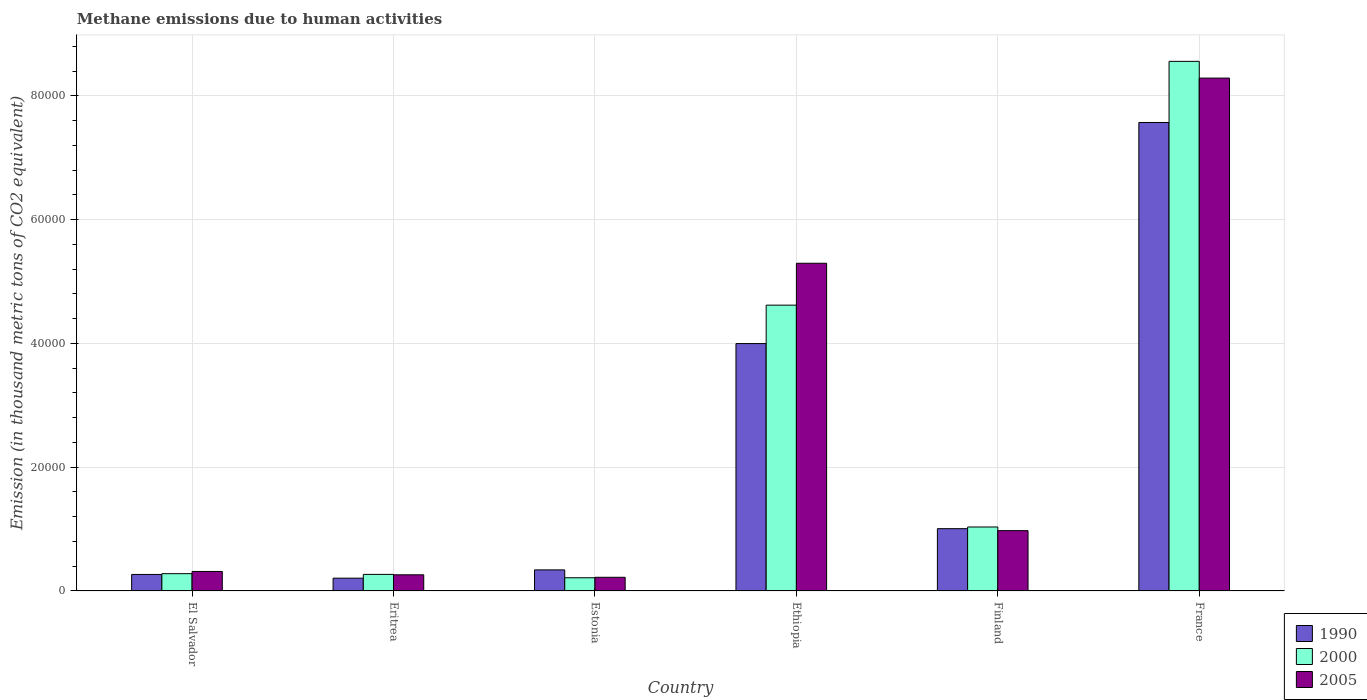How many different coloured bars are there?
Your answer should be very brief. 3. How many bars are there on the 2nd tick from the left?
Provide a short and direct response. 3. How many bars are there on the 1st tick from the right?
Offer a terse response. 3. What is the label of the 1st group of bars from the left?
Provide a succinct answer. El Salvador. What is the amount of methane emitted in 2000 in Ethiopia?
Provide a short and direct response. 4.62e+04. Across all countries, what is the maximum amount of methane emitted in 1990?
Provide a short and direct response. 7.57e+04. Across all countries, what is the minimum amount of methane emitted in 1990?
Offer a very short reply. 2070.6. In which country was the amount of methane emitted in 2005 maximum?
Offer a very short reply. France. In which country was the amount of methane emitted in 2005 minimum?
Ensure brevity in your answer.  Estonia. What is the total amount of methane emitted in 2000 in the graph?
Offer a very short reply. 1.50e+05. What is the difference between the amount of methane emitted in 2000 in Ethiopia and that in Finland?
Keep it short and to the point. 3.59e+04. What is the difference between the amount of methane emitted in 2005 in France and the amount of methane emitted in 2000 in Ethiopia?
Provide a succinct answer. 3.67e+04. What is the average amount of methane emitted in 2000 per country?
Make the answer very short. 2.50e+04. What is the difference between the amount of methane emitted of/in 2000 and amount of methane emitted of/in 2005 in Eritrea?
Make the answer very short. 68.7. What is the ratio of the amount of methane emitted in 2005 in Estonia to that in Finland?
Your response must be concise. 0.23. Is the difference between the amount of methane emitted in 2000 in Eritrea and France greater than the difference between the amount of methane emitted in 2005 in Eritrea and France?
Provide a succinct answer. No. What is the difference between the highest and the second highest amount of methane emitted in 1990?
Give a very brief answer. -3.57e+04. What is the difference between the highest and the lowest amount of methane emitted in 2005?
Offer a terse response. 8.07e+04. In how many countries, is the amount of methane emitted in 2000 greater than the average amount of methane emitted in 2000 taken over all countries?
Provide a succinct answer. 2. What does the 3rd bar from the right in Ethiopia represents?
Offer a terse response. 1990. Is it the case that in every country, the sum of the amount of methane emitted in 2000 and amount of methane emitted in 1990 is greater than the amount of methane emitted in 2005?
Ensure brevity in your answer.  Yes. How many bars are there?
Your answer should be compact. 18. How many countries are there in the graph?
Ensure brevity in your answer.  6. Does the graph contain any zero values?
Ensure brevity in your answer.  No. Where does the legend appear in the graph?
Make the answer very short. Bottom right. How many legend labels are there?
Give a very brief answer. 3. What is the title of the graph?
Your answer should be compact. Methane emissions due to human activities. What is the label or title of the Y-axis?
Your answer should be very brief. Emission (in thousand metric tons of CO2 equivalent). What is the Emission (in thousand metric tons of CO2 equivalent) of 1990 in El Salvador?
Keep it short and to the point. 2672.9. What is the Emission (in thousand metric tons of CO2 equivalent) of 2000 in El Salvador?
Offer a terse response. 2798.1. What is the Emission (in thousand metric tons of CO2 equivalent) in 2005 in El Salvador?
Give a very brief answer. 3152.8. What is the Emission (in thousand metric tons of CO2 equivalent) of 1990 in Eritrea?
Your response must be concise. 2070.6. What is the Emission (in thousand metric tons of CO2 equivalent) of 2000 in Eritrea?
Your answer should be compact. 2682.3. What is the Emission (in thousand metric tons of CO2 equivalent) of 2005 in Eritrea?
Provide a short and direct response. 2613.6. What is the Emission (in thousand metric tons of CO2 equivalent) of 1990 in Estonia?
Your response must be concise. 3408.3. What is the Emission (in thousand metric tons of CO2 equivalent) in 2000 in Estonia?
Give a very brief answer. 2136.3. What is the Emission (in thousand metric tons of CO2 equivalent) of 2005 in Estonia?
Ensure brevity in your answer.  2212.3. What is the Emission (in thousand metric tons of CO2 equivalent) of 1990 in Ethiopia?
Your answer should be compact. 4.00e+04. What is the Emission (in thousand metric tons of CO2 equivalent) in 2000 in Ethiopia?
Provide a short and direct response. 4.62e+04. What is the Emission (in thousand metric tons of CO2 equivalent) of 2005 in Ethiopia?
Your answer should be very brief. 5.30e+04. What is the Emission (in thousand metric tons of CO2 equivalent) in 1990 in Finland?
Provide a succinct answer. 1.01e+04. What is the Emission (in thousand metric tons of CO2 equivalent) of 2000 in Finland?
Your answer should be very brief. 1.03e+04. What is the Emission (in thousand metric tons of CO2 equivalent) of 2005 in Finland?
Ensure brevity in your answer.  9750. What is the Emission (in thousand metric tons of CO2 equivalent) of 1990 in France?
Keep it short and to the point. 7.57e+04. What is the Emission (in thousand metric tons of CO2 equivalent) in 2000 in France?
Your answer should be very brief. 8.56e+04. What is the Emission (in thousand metric tons of CO2 equivalent) in 2005 in France?
Make the answer very short. 8.29e+04. Across all countries, what is the maximum Emission (in thousand metric tons of CO2 equivalent) in 1990?
Offer a very short reply. 7.57e+04. Across all countries, what is the maximum Emission (in thousand metric tons of CO2 equivalent) in 2000?
Provide a short and direct response. 8.56e+04. Across all countries, what is the maximum Emission (in thousand metric tons of CO2 equivalent) of 2005?
Ensure brevity in your answer.  8.29e+04. Across all countries, what is the minimum Emission (in thousand metric tons of CO2 equivalent) in 1990?
Your answer should be very brief. 2070.6. Across all countries, what is the minimum Emission (in thousand metric tons of CO2 equivalent) of 2000?
Provide a short and direct response. 2136.3. Across all countries, what is the minimum Emission (in thousand metric tons of CO2 equivalent) of 2005?
Make the answer very short. 2212.3. What is the total Emission (in thousand metric tons of CO2 equivalent) in 1990 in the graph?
Make the answer very short. 1.34e+05. What is the total Emission (in thousand metric tons of CO2 equivalent) in 2000 in the graph?
Offer a terse response. 1.50e+05. What is the total Emission (in thousand metric tons of CO2 equivalent) of 2005 in the graph?
Your answer should be very brief. 1.54e+05. What is the difference between the Emission (in thousand metric tons of CO2 equivalent) of 1990 in El Salvador and that in Eritrea?
Ensure brevity in your answer.  602.3. What is the difference between the Emission (in thousand metric tons of CO2 equivalent) of 2000 in El Salvador and that in Eritrea?
Provide a short and direct response. 115.8. What is the difference between the Emission (in thousand metric tons of CO2 equivalent) in 2005 in El Salvador and that in Eritrea?
Your response must be concise. 539.2. What is the difference between the Emission (in thousand metric tons of CO2 equivalent) of 1990 in El Salvador and that in Estonia?
Provide a succinct answer. -735.4. What is the difference between the Emission (in thousand metric tons of CO2 equivalent) of 2000 in El Salvador and that in Estonia?
Your response must be concise. 661.8. What is the difference between the Emission (in thousand metric tons of CO2 equivalent) in 2005 in El Salvador and that in Estonia?
Make the answer very short. 940.5. What is the difference between the Emission (in thousand metric tons of CO2 equivalent) of 1990 in El Salvador and that in Ethiopia?
Provide a succinct answer. -3.73e+04. What is the difference between the Emission (in thousand metric tons of CO2 equivalent) in 2000 in El Salvador and that in Ethiopia?
Offer a terse response. -4.34e+04. What is the difference between the Emission (in thousand metric tons of CO2 equivalent) of 2005 in El Salvador and that in Ethiopia?
Your answer should be compact. -4.98e+04. What is the difference between the Emission (in thousand metric tons of CO2 equivalent) of 1990 in El Salvador and that in Finland?
Offer a terse response. -7397.3. What is the difference between the Emission (in thousand metric tons of CO2 equivalent) of 2000 in El Salvador and that in Finland?
Provide a succinct answer. -7542.7. What is the difference between the Emission (in thousand metric tons of CO2 equivalent) in 2005 in El Salvador and that in Finland?
Offer a terse response. -6597.2. What is the difference between the Emission (in thousand metric tons of CO2 equivalent) of 1990 in El Salvador and that in France?
Offer a terse response. -7.30e+04. What is the difference between the Emission (in thousand metric tons of CO2 equivalent) of 2000 in El Salvador and that in France?
Offer a terse response. -8.28e+04. What is the difference between the Emission (in thousand metric tons of CO2 equivalent) in 2005 in El Salvador and that in France?
Provide a short and direct response. -7.97e+04. What is the difference between the Emission (in thousand metric tons of CO2 equivalent) in 1990 in Eritrea and that in Estonia?
Provide a succinct answer. -1337.7. What is the difference between the Emission (in thousand metric tons of CO2 equivalent) of 2000 in Eritrea and that in Estonia?
Offer a very short reply. 546. What is the difference between the Emission (in thousand metric tons of CO2 equivalent) of 2005 in Eritrea and that in Estonia?
Make the answer very short. 401.3. What is the difference between the Emission (in thousand metric tons of CO2 equivalent) in 1990 in Eritrea and that in Ethiopia?
Your answer should be very brief. -3.79e+04. What is the difference between the Emission (in thousand metric tons of CO2 equivalent) in 2000 in Eritrea and that in Ethiopia?
Your answer should be very brief. -4.35e+04. What is the difference between the Emission (in thousand metric tons of CO2 equivalent) in 2005 in Eritrea and that in Ethiopia?
Provide a short and direct response. -5.03e+04. What is the difference between the Emission (in thousand metric tons of CO2 equivalent) in 1990 in Eritrea and that in Finland?
Keep it short and to the point. -7999.6. What is the difference between the Emission (in thousand metric tons of CO2 equivalent) in 2000 in Eritrea and that in Finland?
Your response must be concise. -7658.5. What is the difference between the Emission (in thousand metric tons of CO2 equivalent) in 2005 in Eritrea and that in Finland?
Make the answer very short. -7136.4. What is the difference between the Emission (in thousand metric tons of CO2 equivalent) in 1990 in Eritrea and that in France?
Your answer should be compact. -7.36e+04. What is the difference between the Emission (in thousand metric tons of CO2 equivalent) of 2000 in Eritrea and that in France?
Offer a very short reply. -8.29e+04. What is the difference between the Emission (in thousand metric tons of CO2 equivalent) in 2005 in Eritrea and that in France?
Your answer should be very brief. -8.03e+04. What is the difference between the Emission (in thousand metric tons of CO2 equivalent) of 1990 in Estonia and that in Ethiopia?
Provide a succinct answer. -3.66e+04. What is the difference between the Emission (in thousand metric tons of CO2 equivalent) in 2000 in Estonia and that in Ethiopia?
Your response must be concise. -4.41e+04. What is the difference between the Emission (in thousand metric tons of CO2 equivalent) in 2005 in Estonia and that in Ethiopia?
Your response must be concise. -5.07e+04. What is the difference between the Emission (in thousand metric tons of CO2 equivalent) in 1990 in Estonia and that in Finland?
Keep it short and to the point. -6661.9. What is the difference between the Emission (in thousand metric tons of CO2 equivalent) of 2000 in Estonia and that in Finland?
Ensure brevity in your answer.  -8204.5. What is the difference between the Emission (in thousand metric tons of CO2 equivalent) of 2005 in Estonia and that in Finland?
Offer a very short reply. -7537.7. What is the difference between the Emission (in thousand metric tons of CO2 equivalent) in 1990 in Estonia and that in France?
Your answer should be compact. -7.23e+04. What is the difference between the Emission (in thousand metric tons of CO2 equivalent) of 2000 in Estonia and that in France?
Give a very brief answer. -8.35e+04. What is the difference between the Emission (in thousand metric tons of CO2 equivalent) of 2005 in Estonia and that in France?
Give a very brief answer. -8.07e+04. What is the difference between the Emission (in thousand metric tons of CO2 equivalent) of 1990 in Ethiopia and that in Finland?
Provide a succinct answer. 2.99e+04. What is the difference between the Emission (in thousand metric tons of CO2 equivalent) of 2000 in Ethiopia and that in Finland?
Ensure brevity in your answer.  3.59e+04. What is the difference between the Emission (in thousand metric tons of CO2 equivalent) of 2005 in Ethiopia and that in Finland?
Your answer should be compact. 4.32e+04. What is the difference between the Emission (in thousand metric tons of CO2 equivalent) of 1990 in Ethiopia and that in France?
Offer a terse response. -3.57e+04. What is the difference between the Emission (in thousand metric tons of CO2 equivalent) in 2000 in Ethiopia and that in France?
Provide a short and direct response. -3.94e+04. What is the difference between the Emission (in thousand metric tons of CO2 equivalent) of 2005 in Ethiopia and that in France?
Make the answer very short. -2.99e+04. What is the difference between the Emission (in thousand metric tons of CO2 equivalent) of 1990 in Finland and that in France?
Give a very brief answer. -6.56e+04. What is the difference between the Emission (in thousand metric tons of CO2 equivalent) in 2000 in Finland and that in France?
Provide a succinct answer. -7.52e+04. What is the difference between the Emission (in thousand metric tons of CO2 equivalent) of 2005 in Finland and that in France?
Ensure brevity in your answer.  -7.31e+04. What is the difference between the Emission (in thousand metric tons of CO2 equivalent) of 1990 in El Salvador and the Emission (in thousand metric tons of CO2 equivalent) of 2005 in Eritrea?
Your answer should be very brief. 59.3. What is the difference between the Emission (in thousand metric tons of CO2 equivalent) of 2000 in El Salvador and the Emission (in thousand metric tons of CO2 equivalent) of 2005 in Eritrea?
Provide a succinct answer. 184.5. What is the difference between the Emission (in thousand metric tons of CO2 equivalent) of 1990 in El Salvador and the Emission (in thousand metric tons of CO2 equivalent) of 2000 in Estonia?
Keep it short and to the point. 536.6. What is the difference between the Emission (in thousand metric tons of CO2 equivalent) in 1990 in El Salvador and the Emission (in thousand metric tons of CO2 equivalent) in 2005 in Estonia?
Provide a short and direct response. 460.6. What is the difference between the Emission (in thousand metric tons of CO2 equivalent) in 2000 in El Salvador and the Emission (in thousand metric tons of CO2 equivalent) in 2005 in Estonia?
Provide a succinct answer. 585.8. What is the difference between the Emission (in thousand metric tons of CO2 equivalent) of 1990 in El Salvador and the Emission (in thousand metric tons of CO2 equivalent) of 2000 in Ethiopia?
Make the answer very short. -4.35e+04. What is the difference between the Emission (in thousand metric tons of CO2 equivalent) of 1990 in El Salvador and the Emission (in thousand metric tons of CO2 equivalent) of 2005 in Ethiopia?
Ensure brevity in your answer.  -5.03e+04. What is the difference between the Emission (in thousand metric tons of CO2 equivalent) of 2000 in El Salvador and the Emission (in thousand metric tons of CO2 equivalent) of 2005 in Ethiopia?
Your response must be concise. -5.02e+04. What is the difference between the Emission (in thousand metric tons of CO2 equivalent) of 1990 in El Salvador and the Emission (in thousand metric tons of CO2 equivalent) of 2000 in Finland?
Provide a succinct answer. -7667.9. What is the difference between the Emission (in thousand metric tons of CO2 equivalent) of 1990 in El Salvador and the Emission (in thousand metric tons of CO2 equivalent) of 2005 in Finland?
Provide a succinct answer. -7077.1. What is the difference between the Emission (in thousand metric tons of CO2 equivalent) of 2000 in El Salvador and the Emission (in thousand metric tons of CO2 equivalent) of 2005 in Finland?
Keep it short and to the point. -6951.9. What is the difference between the Emission (in thousand metric tons of CO2 equivalent) of 1990 in El Salvador and the Emission (in thousand metric tons of CO2 equivalent) of 2000 in France?
Your answer should be very brief. -8.29e+04. What is the difference between the Emission (in thousand metric tons of CO2 equivalent) in 1990 in El Salvador and the Emission (in thousand metric tons of CO2 equivalent) in 2005 in France?
Ensure brevity in your answer.  -8.02e+04. What is the difference between the Emission (in thousand metric tons of CO2 equivalent) in 2000 in El Salvador and the Emission (in thousand metric tons of CO2 equivalent) in 2005 in France?
Give a very brief answer. -8.01e+04. What is the difference between the Emission (in thousand metric tons of CO2 equivalent) in 1990 in Eritrea and the Emission (in thousand metric tons of CO2 equivalent) in 2000 in Estonia?
Provide a succinct answer. -65.7. What is the difference between the Emission (in thousand metric tons of CO2 equivalent) in 1990 in Eritrea and the Emission (in thousand metric tons of CO2 equivalent) in 2005 in Estonia?
Give a very brief answer. -141.7. What is the difference between the Emission (in thousand metric tons of CO2 equivalent) of 2000 in Eritrea and the Emission (in thousand metric tons of CO2 equivalent) of 2005 in Estonia?
Ensure brevity in your answer.  470. What is the difference between the Emission (in thousand metric tons of CO2 equivalent) of 1990 in Eritrea and the Emission (in thousand metric tons of CO2 equivalent) of 2000 in Ethiopia?
Give a very brief answer. -4.41e+04. What is the difference between the Emission (in thousand metric tons of CO2 equivalent) in 1990 in Eritrea and the Emission (in thousand metric tons of CO2 equivalent) in 2005 in Ethiopia?
Ensure brevity in your answer.  -5.09e+04. What is the difference between the Emission (in thousand metric tons of CO2 equivalent) in 2000 in Eritrea and the Emission (in thousand metric tons of CO2 equivalent) in 2005 in Ethiopia?
Offer a very short reply. -5.03e+04. What is the difference between the Emission (in thousand metric tons of CO2 equivalent) in 1990 in Eritrea and the Emission (in thousand metric tons of CO2 equivalent) in 2000 in Finland?
Your response must be concise. -8270.2. What is the difference between the Emission (in thousand metric tons of CO2 equivalent) in 1990 in Eritrea and the Emission (in thousand metric tons of CO2 equivalent) in 2005 in Finland?
Provide a succinct answer. -7679.4. What is the difference between the Emission (in thousand metric tons of CO2 equivalent) in 2000 in Eritrea and the Emission (in thousand metric tons of CO2 equivalent) in 2005 in Finland?
Provide a short and direct response. -7067.7. What is the difference between the Emission (in thousand metric tons of CO2 equivalent) of 1990 in Eritrea and the Emission (in thousand metric tons of CO2 equivalent) of 2000 in France?
Your answer should be very brief. -8.35e+04. What is the difference between the Emission (in thousand metric tons of CO2 equivalent) of 1990 in Eritrea and the Emission (in thousand metric tons of CO2 equivalent) of 2005 in France?
Your answer should be very brief. -8.08e+04. What is the difference between the Emission (in thousand metric tons of CO2 equivalent) of 2000 in Eritrea and the Emission (in thousand metric tons of CO2 equivalent) of 2005 in France?
Keep it short and to the point. -8.02e+04. What is the difference between the Emission (in thousand metric tons of CO2 equivalent) of 1990 in Estonia and the Emission (in thousand metric tons of CO2 equivalent) of 2000 in Ethiopia?
Ensure brevity in your answer.  -4.28e+04. What is the difference between the Emission (in thousand metric tons of CO2 equivalent) of 1990 in Estonia and the Emission (in thousand metric tons of CO2 equivalent) of 2005 in Ethiopia?
Give a very brief answer. -4.96e+04. What is the difference between the Emission (in thousand metric tons of CO2 equivalent) in 2000 in Estonia and the Emission (in thousand metric tons of CO2 equivalent) in 2005 in Ethiopia?
Give a very brief answer. -5.08e+04. What is the difference between the Emission (in thousand metric tons of CO2 equivalent) of 1990 in Estonia and the Emission (in thousand metric tons of CO2 equivalent) of 2000 in Finland?
Give a very brief answer. -6932.5. What is the difference between the Emission (in thousand metric tons of CO2 equivalent) in 1990 in Estonia and the Emission (in thousand metric tons of CO2 equivalent) in 2005 in Finland?
Offer a terse response. -6341.7. What is the difference between the Emission (in thousand metric tons of CO2 equivalent) in 2000 in Estonia and the Emission (in thousand metric tons of CO2 equivalent) in 2005 in Finland?
Give a very brief answer. -7613.7. What is the difference between the Emission (in thousand metric tons of CO2 equivalent) in 1990 in Estonia and the Emission (in thousand metric tons of CO2 equivalent) in 2000 in France?
Provide a succinct answer. -8.22e+04. What is the difference between the Emission (in thousand metric tons of CO2 equivalent) in 1990 in Estonia and the Emission (in thousand metric tons of CO2 equivalent) in 2005 in France?
Offer a terse response. -7.95e+04. What is the difference between the Emission (in thousand metric tons of CO2 equivalent) of 2000 in Estonia and the Emission (in thousand metric tons of CO2 equivalent) of 2005 in France?
Your answer should be very brief. -8.07e+04. What is the difference between the Emission (in thousand metric tons of CO2 equivalent) in 1990 in Ethiopia and the Emission (in thousand metric tons of CO2 equivalent) in 2000 in Finland?
Your answer should be very brief. 2.96e+04. What is the difference between the Emission (in thousand metric tons of CO2 equivalent) of 1990 in Ethiopia and the Emission (in thousand metric tons of CO2 equivalent) of 2005 in Finland?
Ensure brevity in your answer.  3.02e+04. What is the difference between the Emission (in thousand metric tons of CO2 equivalent) of 2000 in Ethiopia and the Emission (in thousand metric tons of CO2 equivalent) of 2005 in Finland?
Make the answer very short. 3.64e+04. What is the difference between the Emission (in thousand metric tons of CO2 equivalent) of 1990 in Ethiopia and the Emission (in thousand metric tons of CO2 equivalent) of 2000 in France?
Provide a succinct answer. -4.56e+04. What is the difference between the Emission (in thousand metric tons of CO2 equivalent) in 1990 in Ethiopia and the Emission (in thousand metric tons of CO2 equivalent) in 2005 in France?
Make the answer very short. -4.29e+04. What is the difference between the Emission (in thousand metric tons of CO2 equivalent) of 2000 in Ethiopia and the Emission (in thousand metric tons of CO2 equivalent) of 2005 in France?
Provide a succinct answer. -3.67e+04. What is the difference between the Emission (in thousand metric tons of CO2 equivalent) of 1990 in Finland and the Emission (in thousand metric tons of CO2 equivalent) of 2000 in France?
Offer a terse response. -7.55e+04. What is the difference between the Emission (in thousand metric tons of CO2 equivalent) of 1990 in Finland and the Emission (in thousand metric tons of CO2 equivalent) of 2005 in France?
Provide a short and direct response. -7.28e+04. What is the difference between the Emission (in thousand metric tons of CO2 equivalent) of 2000 in Finland and the Emission (in thousand metric tons of CO2 equivalent) of 2005 in France?
Offer a terse response. -7.25e+04. What is the average Emission (in thousand metric tons of CO2 equivalent) in 1990 per country?
Your answer should be compact. 2.23e+04. What is the average Emission (in thousand metric tons of CO2 equivalent) of 2000 per country?
Provide a short and direct response. 2.50e+04. What is the average Emission (in thousand metric tons of CO2 equivalent) of 2005 per country?
Provide a short and direct response. 2.56e+04. What is the difference between the Emission (in thousand metric tons of CO2 equivalent) in 1990 and Emission (in thousand metric tons of CO2 equivalent) in 2000 in El Salvador?
Your response must be concise. -125.2. What is the difference between the Emission (in thousand metric tons of CO2 equivalent) of 1990 and Emission (in thousand metric tons of CO2 equivalent) of 2005 in El Salvador?
Your response must be concise. -479.9. What is the difference between the Emission (in thousand metric tons of CO2 equivalent) of 2000 and Emission (in thousand metric tons of CO2 equivalent) of 2005 in El Salvador?
Provide a short and direct response. -354.7. What is the difference between the Emission (in thousand metric tons of CO2 equivalent) of 1990 and Emission (in thousand metric tons of CO2 equivalent) of 2000 in Eritrea?
Keep it short and to the point. -611.7. What is the difference between the Emission (in thousand metric tons of CO2 equivalent) of 1990 and Emission (in thousand metric tons of CO2 equivalent) of 2005 in Eritrea?
Provide a succinct answer. -543. What is the difference between the Emission (in thousand metric tons of CO2 equivalent) in 2000 and Emission (in thousand metric tons of CO2 equivalent) in 2005 in Eritrea?
Provide a short and direct response. 68.7. What is the difference between the Emission (in thousand metric tons of CO2 equivalent) of 1990 and Emission (in thousand metric tons of CO2 equivalent) of 2000 in Estonia?
Offer a terse response. 1272. What is the difference between the Emission (in thousand metric tons of CO2 equivalent) of 1990 and Emission (in thousand metric tons of CO2 equivalent) of 2005 in Estonia?
Offer a terse response. 1196. What is the difference between the Emission (in thousand metric tons of CO2 equivalent) in 2000 and Emission (in thousand metric tons of CO2 equivalent) in 2005 in Estonia?
Provide a short and direct response. -76. What is the difference between the Emission (in thousand metric tons of CO2 equivalent) in 1990 and Emission (in thousand metric tons of CO2 equivalent) in 2000 in Ethiopia?
Give a very brief answer. -6210.5. What is the difference between the Emission (in thousand metric tons of CO2 equivalent) of 1990 and Emission (in thousand metric tons of CO2 equivalent) of 2005 in Ethiopia?
Your response must be concise. -1.30e+04. What is the difference between the Emission (in thousand metric tons of CO2 equivalent) of 2000 and Emission (in thousand metric tons of CO2 equivalent) of 2005 in Ethiopia?
Ensure brevity in your answer.  -6767.8. What is the difference between the Emission (in thousand metric tons of CO2 equivalent) in 1990 and Emission (in thousand metric tons of CO2 equivalent) in 2000 in Finland?
Offer a very short reply. -270.6. What is the difference between the Emission (in thousand metric tons of CO2 equivalent) of 1990 and Emission (in thousand metric tons of CO2 equivalent) of 2005 in Finland?
Your answer should be very brief. 320.2. What is the difference between the Emission (in thousand metric tons of CO2 equivalent) in 2000 and Emission (in thousand metric tons of CO2 equivalent) in 2005 in Finland?
Offer a very short reply. 590.8. What is the difference between the Emission (in thousand metric tons of CO2 equivalent) in 1990 and Emission (in thousand metric tons of CO2 equivalent) in 2000 in France?
Ensure brevity in your answer.  -9878.9. What is the difference between the Emission (in thousand metric tons of CO2 equivalent) in 1990 and Emission (in thousand metric tons of CO2 equivalent) in 2005 in France?
Ensure brevity in your answer.  -7175.9. What is the difference between the Emission (in thousand metric tons of CO2 equivalent) in 2000 and Emission (in thousand metric tons of CO2 equivalent) in 2005 in France?
Offer a very short reply. 2703. What is the ratio of the Emission (in thousand metric tons of CO2 equivalent) in 1990 in El Salvador to that in Eritrea?
Give a very brief answer. 1.29. What is the ratio of the Emission (in thousand metric tons of CO2 equivalent) in 2000 in El Salvador to that in Eritrea?
Offer a terse response. 1.04. What is the ratio of the Emission (in thousand metric tons of CO2 equivalent) in 2005 in El Salvador to that in Eritrea?
Provide a short and direct response. 1.21. What is the ratio of the Emission (in thousand metric tons of CO2 equivalent) of 1990 in El Salvador to that in Estonia?
Keep it short and to the point. 0.78. What is the ratio of the Emission (in thousand metric tons of CO2 equivalent) in 2000 in El Salvador to that in Estonia?
Provide a short and direct response. 1.31. What is the ratio of the Emission (in thousand metric tons of CO2 equivalent) in 2005 in El Salvador to that in Estonia?
Ensure brevity in your answer.  1.43. What is the ratio of the Emission (in thousand metric tons of CO2 equivalent) in 1990 in El Salvador to that in Ethiopia?
Offer a very short reply. 0.07. What is the ratio of the Emission (in thousand metric tons of CO2 equivalent) in 2000 in El Salvador to that in Ethiopia?
Keep it short and to the point. 0.06. What is the ratio of the Emission (in thousand metric tons of CO2 equivalent) of 2005 in El Salvador to that in Ethiopia?
Your response must be concise. 0.06. What is the ratio of the Emission (in thousand metric tons of CO2 equivalent) in 1990 in El Salvador to that in Finland?
Offer a very short reply. 0.27. What is the ratio of the Emission (in thousand metric tons of CO2 equivalent) in 2000 in El Salvador to that in Finland?
Your response must be concise. 0.27. What is the ratio of the Emission (in thousand metric tons of CO2 equivalent) in 2005 in El Salvador to that in Finland?
Give a very brief answer. 0.32. What is the ratio of the Emission (in thousand metric tons of CO2 equivalent) of 1990 in El Salvador to that in France?
Your answer should be compact. 0.04. What is the ratio of the Emission (in thousand metric tons of CO2 equivalent) of 2000 in El Salvador to that in France?
Give a very brief answer. 0.03. What is the ratio of the Emission (in thousand metric tons of CO2 equivalent) of 2005 in El Salvador to that in France?
Your answer should be compact. 0.04. What is the ratio of the Emission (in thousand metric tons of CO2 equivalent) in 1990 in Eritrea to that in Estonia?
Keep it short and to the point. 0.61. What is the ratio of the Emission (in thousand metric tons of CO2 equivalent) of 2000 in Eritrea to that in Estonia?
Your answer should be compact. 1.26. What is the ratio of the Emission (in thousand metric tons of CO2 equivalent) in 2005 in Eritrea to that in Estonia?
Keep it short and to the point. 1.18. What is the ratio of the Emission (in thousand metric tons of CO2 equivalent) in 1990 in Eritrea to that in Ethiopia?
Ensure brevity in your answer.  0.05. What is the ratio of the Emission (in thousand metric tons of CO2 equivalent) in 2000 in Eritrea to that in Ethiopia?
Give a very brief answer. 0.06. What is the ratio of the Emission (in thousand metric tons of CO2 equivalent) of 2005 in Eritrea to that in Ethiopia?
Your answer should be very brief. 0.05. What is the ratio of the Emission (in thousand metric tons of CO2 equivalent) of 1990 in Eritrea to that in Finland?
Your answer should be compact. 0.21. What is the ratio of the Emission (in thousand metric tons of CO2 equivalent) in 2000 in Eritrea to that in Finland?
Offer a terse response. 0.26. What is the ratio of the Emission (in thousand metric tons of CO2 equivalent) of 2005 in Eritrea to that in Finland?
Your answer should be very brief. 0.27. What is the ratio of the Emission (in thousand metric tons of CO2 equivalent) of 1990 in Eritrea to that in France?
Ensure brevity in your answer.  0.03. What is the ratio of the Emission (in thousand metric tons of CO2 equivalent) of 2000 in Eritrea to that in France?
Ensure brevity in your answer.  0.03. What is the ratio of the Emission (in thousand metric tons of CO2 equivalent) of 2005 in Eritrea to that in France?
Ensure brevity in your answer.  0.03. What is the ratio of the Emission (in thousand metric tons of CO2 equivalent) of 1990 in Estonia to that in Ethiopia?
Your answer should be compact. 0.09. What is the ratio of the Emission (in thousand metric tons of CO2 equivalent) of 2000 in Estonia to that in Ethiopia?
Ensure brevity in your answer.  0.05. What is the ratio of the Emission (in thousand metric tons of CO2 equivalent) of 2005 in Estonia to that in Ethiopia?
Provide a succinct answer. 0.04. What is the ratio of the Emission (in thousand metric tons of CO2 equivalent) in 1990 in Estonia to that in Finland?
Your answer should be compact. 0.34. What is the ratio of the Emission (in thousand metric tons of CO2 equivalent) of 2000 in Estonia to that in Finland?
Make the answer very short. 0.21. What is the ratio of the Emission (in thousand metric tons of CO2 equivalent) in 2005 in Estonia to that in Finland?
Your answer should be very brief. 0.23. What is the ratio of the Emission (in thousand metric tons of CO2 equivalent) of 1990 in Estonia to that in France?
Provide a succinct answer. 0.04. What is the ratio of the Emission (in thousand metric tons of CO2 equivalent) of 2000 in Estonia to that in France?
Provide a short and direct response. 0.03. What is the ratio of the Emission (in thousand metric tons of CO2 equivalent) in 2005 in Estonia to that in France?
Keep it short and to the point. 0.03. What is the ratio of the Emission (in thousand metric tons of CO2 equivalent) of 1990 in Ethiopia to that in Finland?
Offer a very short reply. 3.97. What is the ratio of the Emission (in thousand metric tons of CO2 equivalent) of 2000 in Ethiopia to that in Finland?
Make the answer very short. 4.47. What is the ratio of the Emission (in thousand metric tons of CO2 equivalent) of 2005 in Ethiopia to that in Finland?
Provide a short and direct response. 5.43. What is the ratio of the Emission (in thousand metric tons of CO2 equivalent) in 1990 in Ethiopia to that in France?
Keep it short and to the point. 0.53. What is the ratio of the Emission (in thousand metric tons of CO2 equivalent) of 2000 in Ethiopia to that in France?
Keep it short and to the point. 0.54. What is the ratio of the Emission (in thousand metric tons of CO2 equivalent) of 2005 in Ethiopia to that in France?
Give a very brief answer. 0.64. What is the ratio of the Emission (in thousand metric tons of CO2 equivalent) in 1990 in Finland to that in France?
Keep it short and to the point. 0.13. What is the ratio of the Emission (in thousand metric tons of CO2 equivalent) in 2000 in Finland to that in France?
Your response must be concise. 0.12. What is the ratio of the Emission (in thousand metric tons of CO2 equivalent) in 2005 in Finland to that in France?
Make the answer very short. 0.12. What is the difference between the highest and the second highest Emission (in thousand metric tons of CO2 equivalent) in 1990?
Offer a terse response. 3.57e+04. What is the difference between the highest and the second highest Emission (in thousand metric tons of CO2 equivalent) in 2000?
Your response must be concise. 3.94e+04. What is the difference between the highest and the second highest Emission (in thousand metric tons of CO2 equivalent) of 2005?
Make the answer very short. 2.99e+04. What is the difference between the highest and the lowest Emission (in thousand metric tons of CO2 equivalent) in 1990?
Your response must be concise. 7.36e+04. What is the difference between the highest and the lowest Emission (in thousand metric tons of CO2 equivalent) in 2000?
Keep it short and to the point. 8.35e+04. What is the difference between the highest and the lowest Emission (in thousand metric tons of CO2 equivalent) of 2005?
Offer a terse response. 8.07e+04. 